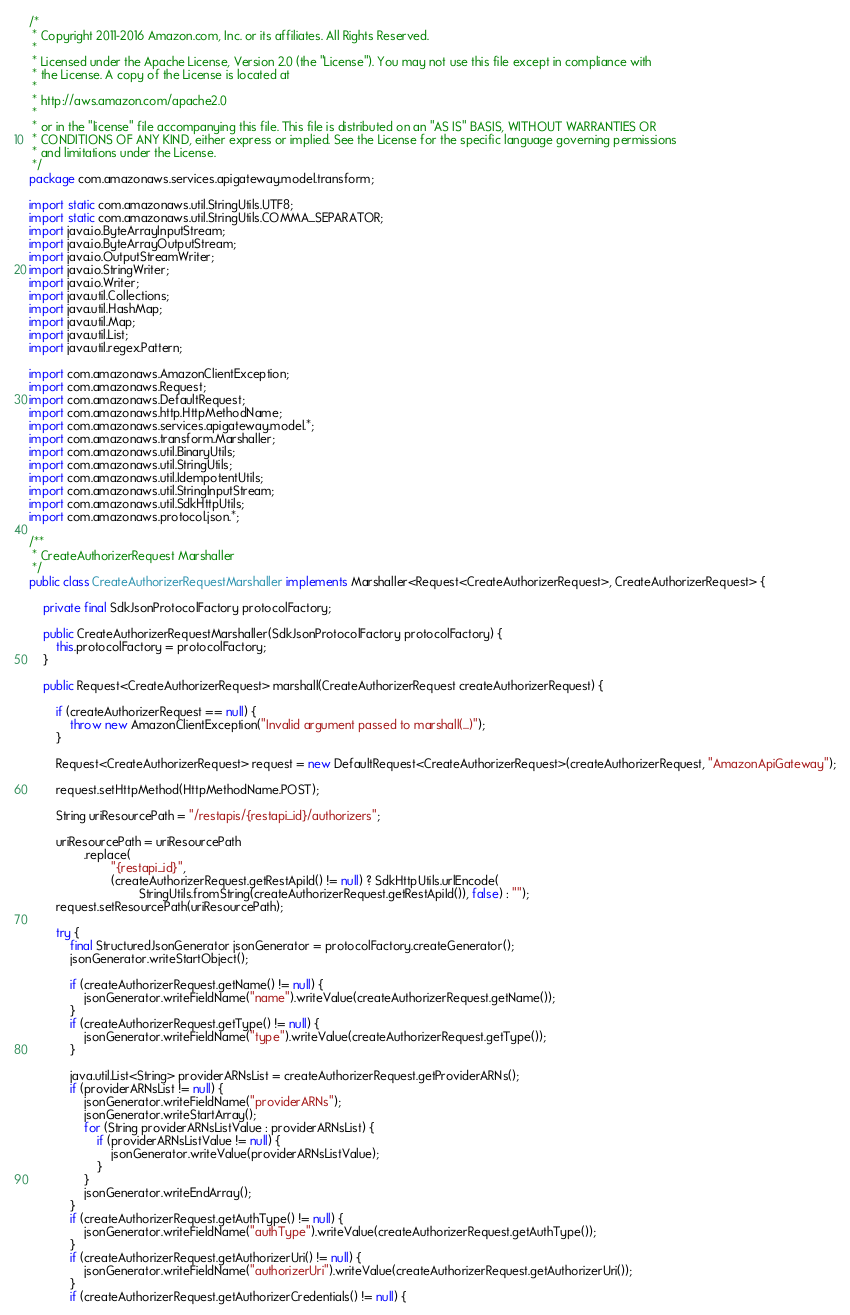Convert code to text. <code><loc_0><loc_0><loc_500><loc_500><_Java_>/*
 * Copyright 2011-2016 Amazon.com, Inc. or its affiliates. All Rights Reserved.
 * 
 * Licensed under the Apache License, Version 2.0 (the "License"). You may not use this file except in compliance with
 * the License. A copy of the License is located at
 * 
 * http://aws.amazon.com/apache2.0
 * 
 * or in the "license" file accompanying this file. This file is distributed on an "AS IS" BASIS, WITHOUT WARRANTIES OR
 * CONDITIONS OF ANY KIND, either express or implied. See the License for the specific language governing permissions
 * and limitations under the License.
 */
package com.amazonaws.services.apigateway.model.transform;

import static com.amazonaws.util.StringUtils.UTF8;
import static com.amazonaws.util.StringUtils.COMMA_SEPARATOR;
import java.io.ByteArrayInputStream;
import java.io.ByteArrayOutputStream;
import java.io.OutputStreamWriter;
import java.io.StringWriter;
import java.io.Writer;
import java.util.Collections;
import java.util.HashMap;
import java.util.Map;
import java.util.List;
import java.util.regex.Pattern;

import com.amazonaws.AmazonClientException;
import com.amazonaws.Request;
import com.amazonaws.DefaultRequest;
import com.amazonaws.http.HttpMethodName;
import com.amazonaws.services.apigateway.model.*;
import com.amazonaws.transform.Marshaller;
import com.amazonaws.util.BinaryUtils;
import com.amazonaws.util.StringUtils;
import com.amazonaws.util.IdempotentUtils;
import com.amazonaws.util.StringInputStream;
import com.amazonaws.util.SdkHttpUtils;
import com.amazonaws.protocol.json.*;

/**
 * CreateAuthorizerRequest Marshaller
 */
public class CreateAuthorizerRequestMarshaller implements Marshaller<Request<CreateAuthorizerRequest>, CreateAuthorizerRequest> {

    private final SdkJsonProtocolFactory protocolFactory;

    public CreateAuthorizerRequestMarshaller(SdkJsonProtocolFactory protocolFactory) {
        this.protocolFactory = protocolFactory;
    }

    public Request<CreateAuthorizerRequest> marshall(CreateAuthorizerRequest createAuthorizerRequest) {

        if (createAuthorizerRequest == null) {
            throw new AmazonClientException("Invalid argument passed to marshall(...)");
        }

        Request<CreateAuthorizerRequest> request = new DefaultRequest<CreateAuthorizerRequest>(createAuthorizerRequest, "AmazonApiGateway");

        request.setHttpMethod(HttpMethodName.POST);

        String uriResourcePath = "/restapis/{restapi_id}/authorizers";

        uriResourcePath = uriResourcePath
                .replace(
                        "{restapi_id}",
                        (createAuthorizerRequest.getRestApiId() != null) ? SdkHttpUtils.urlEncode(
                                StringUtils.fromString(createAuthorizerRequest.getRestApiId()), false) : "");
        request.setResourcePath(uriResourcePath);

        try {
            final StructuredJsonGenerator jsonGenerator = protocolFactory.createGenerator();
            jsonGenerator.writeStartObject();

            if (createAuthorizerRequest.getName() != null) {
                jsonGenerator.writeFieldName("name").writeValue(createAuthorizerRequest.getName());
            }
            if (createAuthorizerRequest.getType() != null) {
                jsonGenerator.writeFieldName("type").writeValue(createAuthorizerRequest.getType());
            }

            java.util.List<String> providerARNsList = createAuthorizerRequest.getProviderARNs();
            if (providerARNsList != null) {
                jsonGenerator.writeFieldName("providerARNs");
                jsonGenerator.writeStartArray();
                for (String providerARNsListValue : providerARNsList) {
                    if (providerARNsListValue != null) {
                        jsonGenerator.writeValue(providerARNsListValue);
                    }
                }
                jsonGenerator.writeEndArray();
            }
            if (createAuthorizerRequest.getAuthType() != null) {
                jsonGenerator.writeFieldName("authType").writeValue(createAuthorizerRequest.getAuthType());
            }
            if (createAuthorizerRequest.getAuthorizerUri() != null) {
                jsonGenerator.writeFieldName("authorizerUri").writeValue(createAuthorizerRequest.getAuthorizerUri());
            }
            if (createAuthorizerRequest.getAuthorizerCredentials() != null) {</code> 